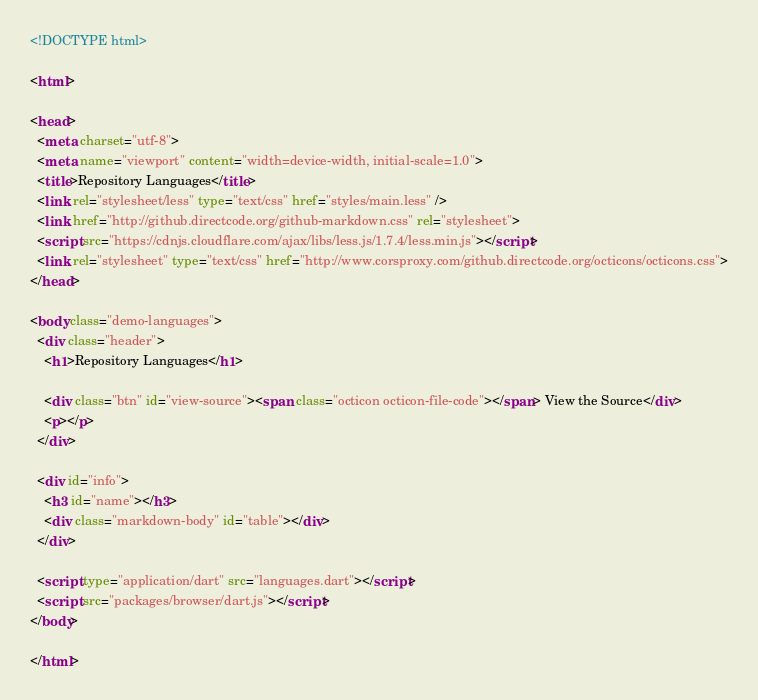<code> <loc_0><loc_0><loc_500><loc_500><_HTML_><!DOCTYPE html>

<html>

<head>
  <meta charset="utf-8">
  <meta name="viewport" content="width=device-width, initial-scale=1.0">
  <title>Repository Languages</title>
  <link rel="stylesheet/less" type="text/css" href="styles/main.less" />
  <link href="http://github.directcode.org/github-markdown.css" rel="stylesheet">
  <script src="https://cdnjs.cloudflare.com/ajax/libs/less.js/1.7.4/less.min.js"></script>
  <link rel="stylesheet" type="text/css" href="http://www.corsproxy.com/github.directcode.org/octicons/octicons.css">
</head>

<body class="demo-languages">
  <div class="header">
    <h1>Repository Languages</h1>

    <div class="btn" id="view-source"><span class="octicon octicon-file-code"></span> View the Source</div>
    <p></p>
  </div>

  <div id="info">
    <h3 id="name"></h3>
    <div class="markdown-body" id="table"></div>
  </div>

  <script type="application/dart" src="languages.dart"></script>
  <script src="packages/browser/dart.js"></script>
</body>

</html>
</code> 